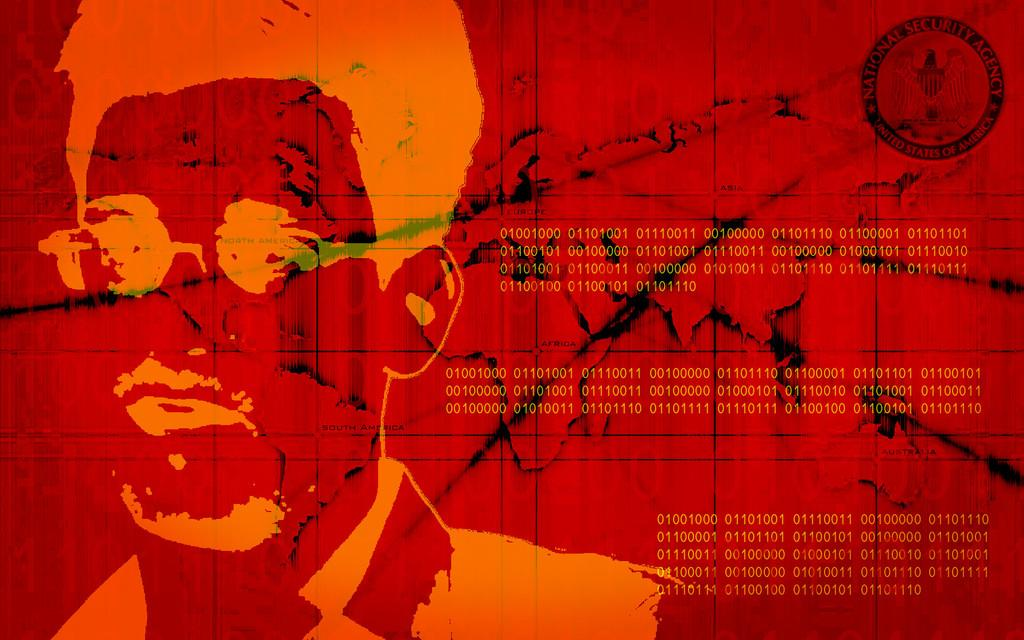What type of editing has been done to the image? The image is edited, but the specific type of editing is not mentioned in the facts. What can be seen on the person's face in the image? There is a person's face in the image, but the facts do not provide any details about the person's facial features or expressions. What does the text in the image say? The facts do not mention the content of the text in the image. What type of fang can be seen in the person's mouth in the image? There is no mention of a fang or any other specific facial feature in the image, so we cannot answer this question. 